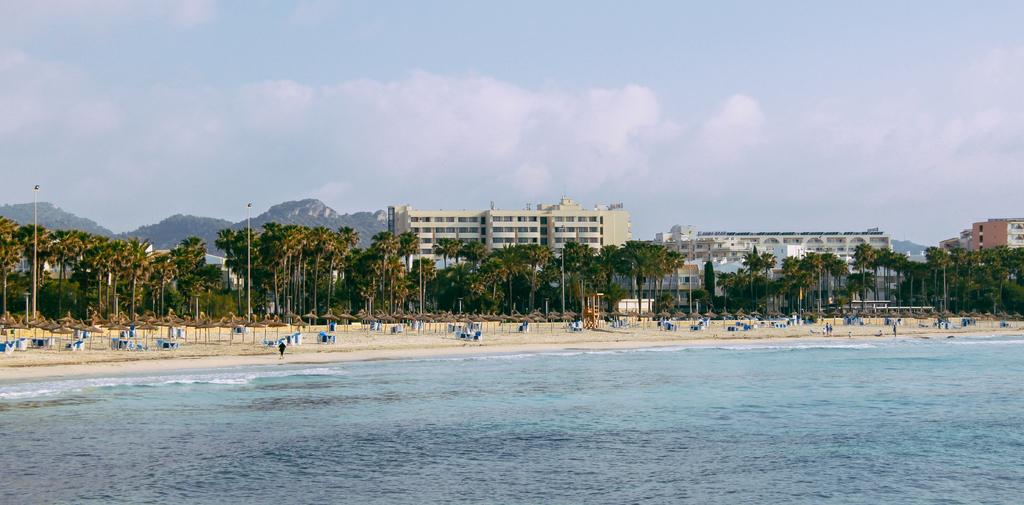What type of structures can be seen in the image? There are buildings in the image. What other objects can be seen in the image besides buildings? There are poles, trees, mountains, windows, lights, and objects on the ground visible in the image. What is visible in the background of the image? The sky is visible in the background of the image, with clouds present. How many stamps are on the buildings in the image? There are no stamps present on the buildings in the image. What type of work is being done on the poles in the image? There is no work being done on the poles in the image; they are simply standing upright. 